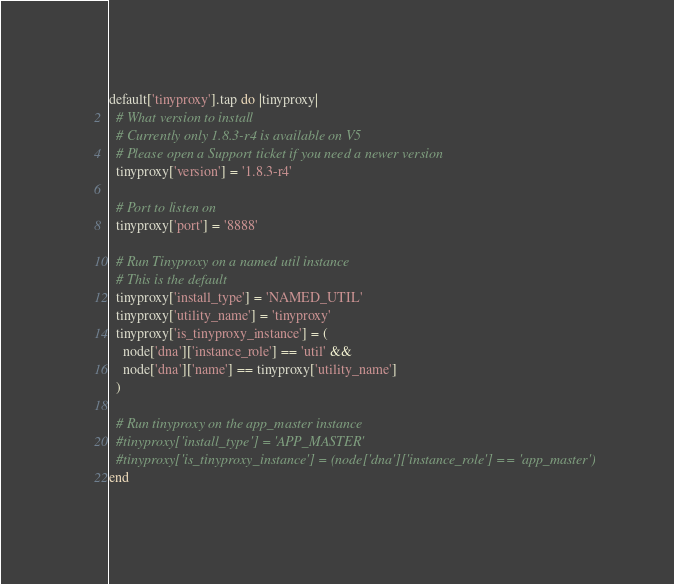<code> <loc_0><loc_0><loc_500><loc_500><_Ruby_>default['tinyproxy'].tap do |tinyproxy|
  # What version to install
  # Currently only 1.8.3-r4 is available on V5
  # Please open a Support ticket if you need a newer version
  tinyproxy['version'] = '1.8.3-r4'

  # Port to listen on
  tinyproxy['port'] = '8888'

  # Run Tinyproxy on a named util instance
  # This is the default
  tinyproxy['install_type'] = 'NAMED_UTIL'
  tinyproxy['utility_name'] = 'tinyproxy'
  tinyproxy['is_tinyproxy_instance'] = (
    node['dna']['instance_role'] == 'util' &&
    node['dna']['name'] == tinyproxy['utility_name']
  )

  # Run tinyproxy on the app_master instance
  #tinyproxy['install_type'] = 'APP_MASTER'
  #tinyproxy['is_tinyproxy_instance'] = (node['dna']['instance_role'] == 'app_master')
end
</code> 